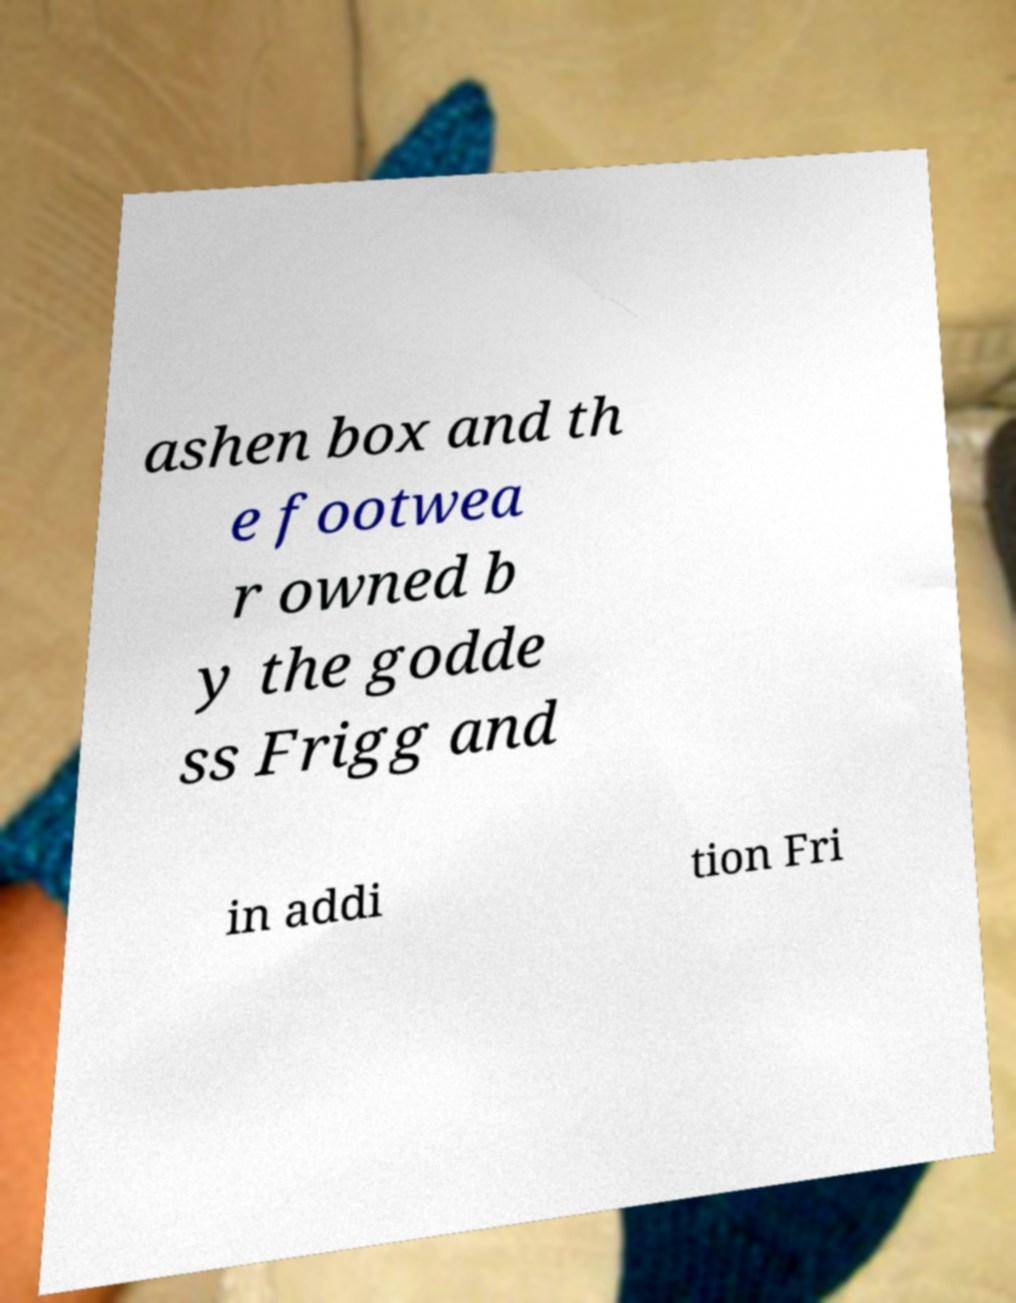There's text embedded in this image that I need extracted. Can you transcribe it verbatim? ashen box and th e footwea r owned b y the godde ss Frigg and in addi tion Fri 